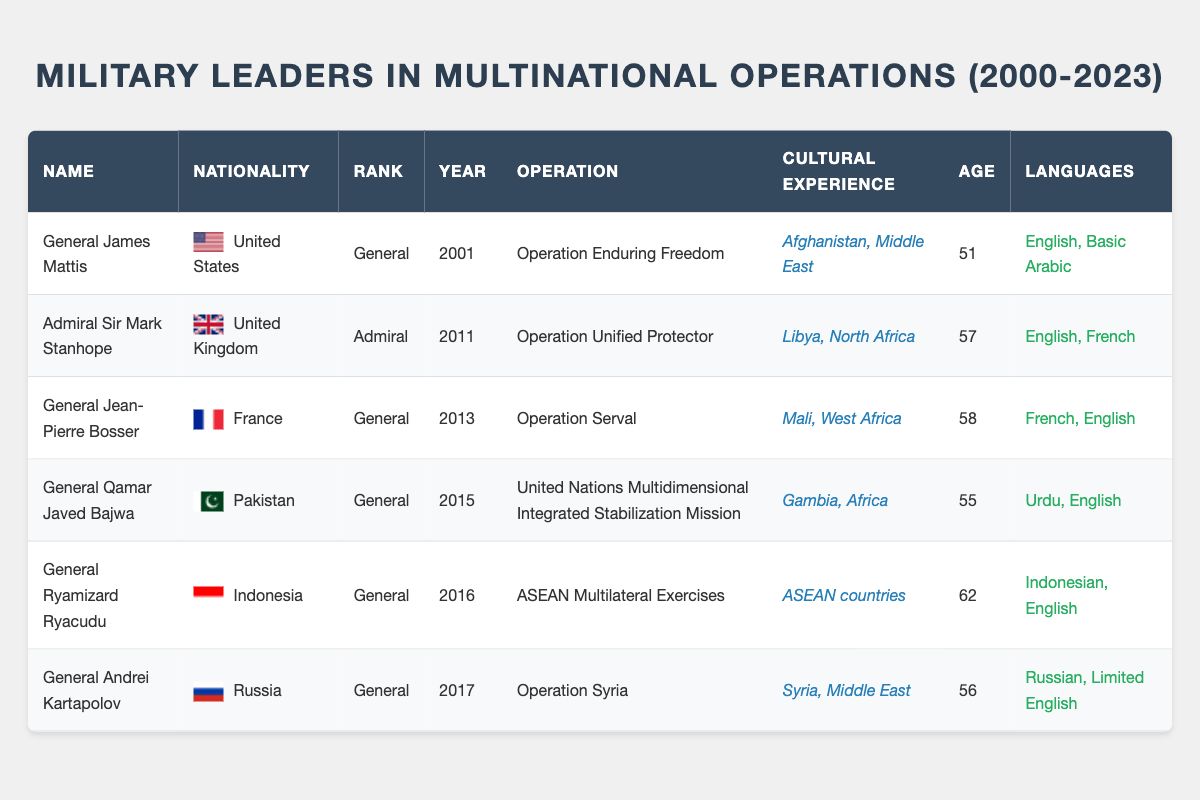What year did General James Mattis participate in his multinational operation? General James Mattis participated in his multinational operation in the year 2001, as stated in the "year_of_multinational_operation" column.
Answer: 2001 Which military leader is from Pakistan? The military leader from Pakistan is General Qamar Javed Bajwa, as identified in the "nationality" column.
Answer: General Qamar Javed Bajwa What is the average age of the military leaders listed in the table? To find the average age, we first sum the ages of each military leader: 51 + 57 + 58 + 55 + 62 + 56 = 299. Then, we divide by the total number of leaders (6): 299/6 = 49.83, rounding to the nearest whole number gives us 50.
Answer: 50 Does General Ryamizard Ryacudu speak French? General Ryamizard Ryacudu's languages spoken include Indonesian and English, but not French, as listed in the "languages_spoken" column for his entry.
Answer: No Which operation had military leaders with cultural experiences in Africa? The operations with military leaders who have cultural experiences in Africa are "United Nations Multidimensional Integrated Stabilization Mission" led by General Qamar Javed Bajwa and "Operation Serval" led by General Jean-Pierre Bosser. This information is found under the "cultural_experience" column.
Answer: United Nations Multidimensional Integrated Stabilization Mission, Operation Serval In which year did the majority of military leaders begin their multinational operations, specifically those listed from 2011 onwards? The data indicate that from 2011 onwards, there were three military leaders who commenced operations: Admiral Sir Mark Stanhope in 2011, General Jean-Pierre Bosser in 2013, General Qamar Javed Bajwa in 2015, General Ryamizard Ryacudu in 2016, and General Andrei Kartapolov in 2017. The earliest year among these is 2011.
Answer: 2011 How many of the military leaders speak English? In the table, five of the six military leaders listed speak English as one of their languages. This conclusion is derived from the "languages_spoken" column where English appears in all but one entry.
Answer: Five What is the cultural experience of General Andrei Kartapolov? General Andrei Kartapolov's cultural experience includes Syria and the Middle East, as indicated in the "cultural_experience" column for his entry.
Answer: Syria, Middle East 